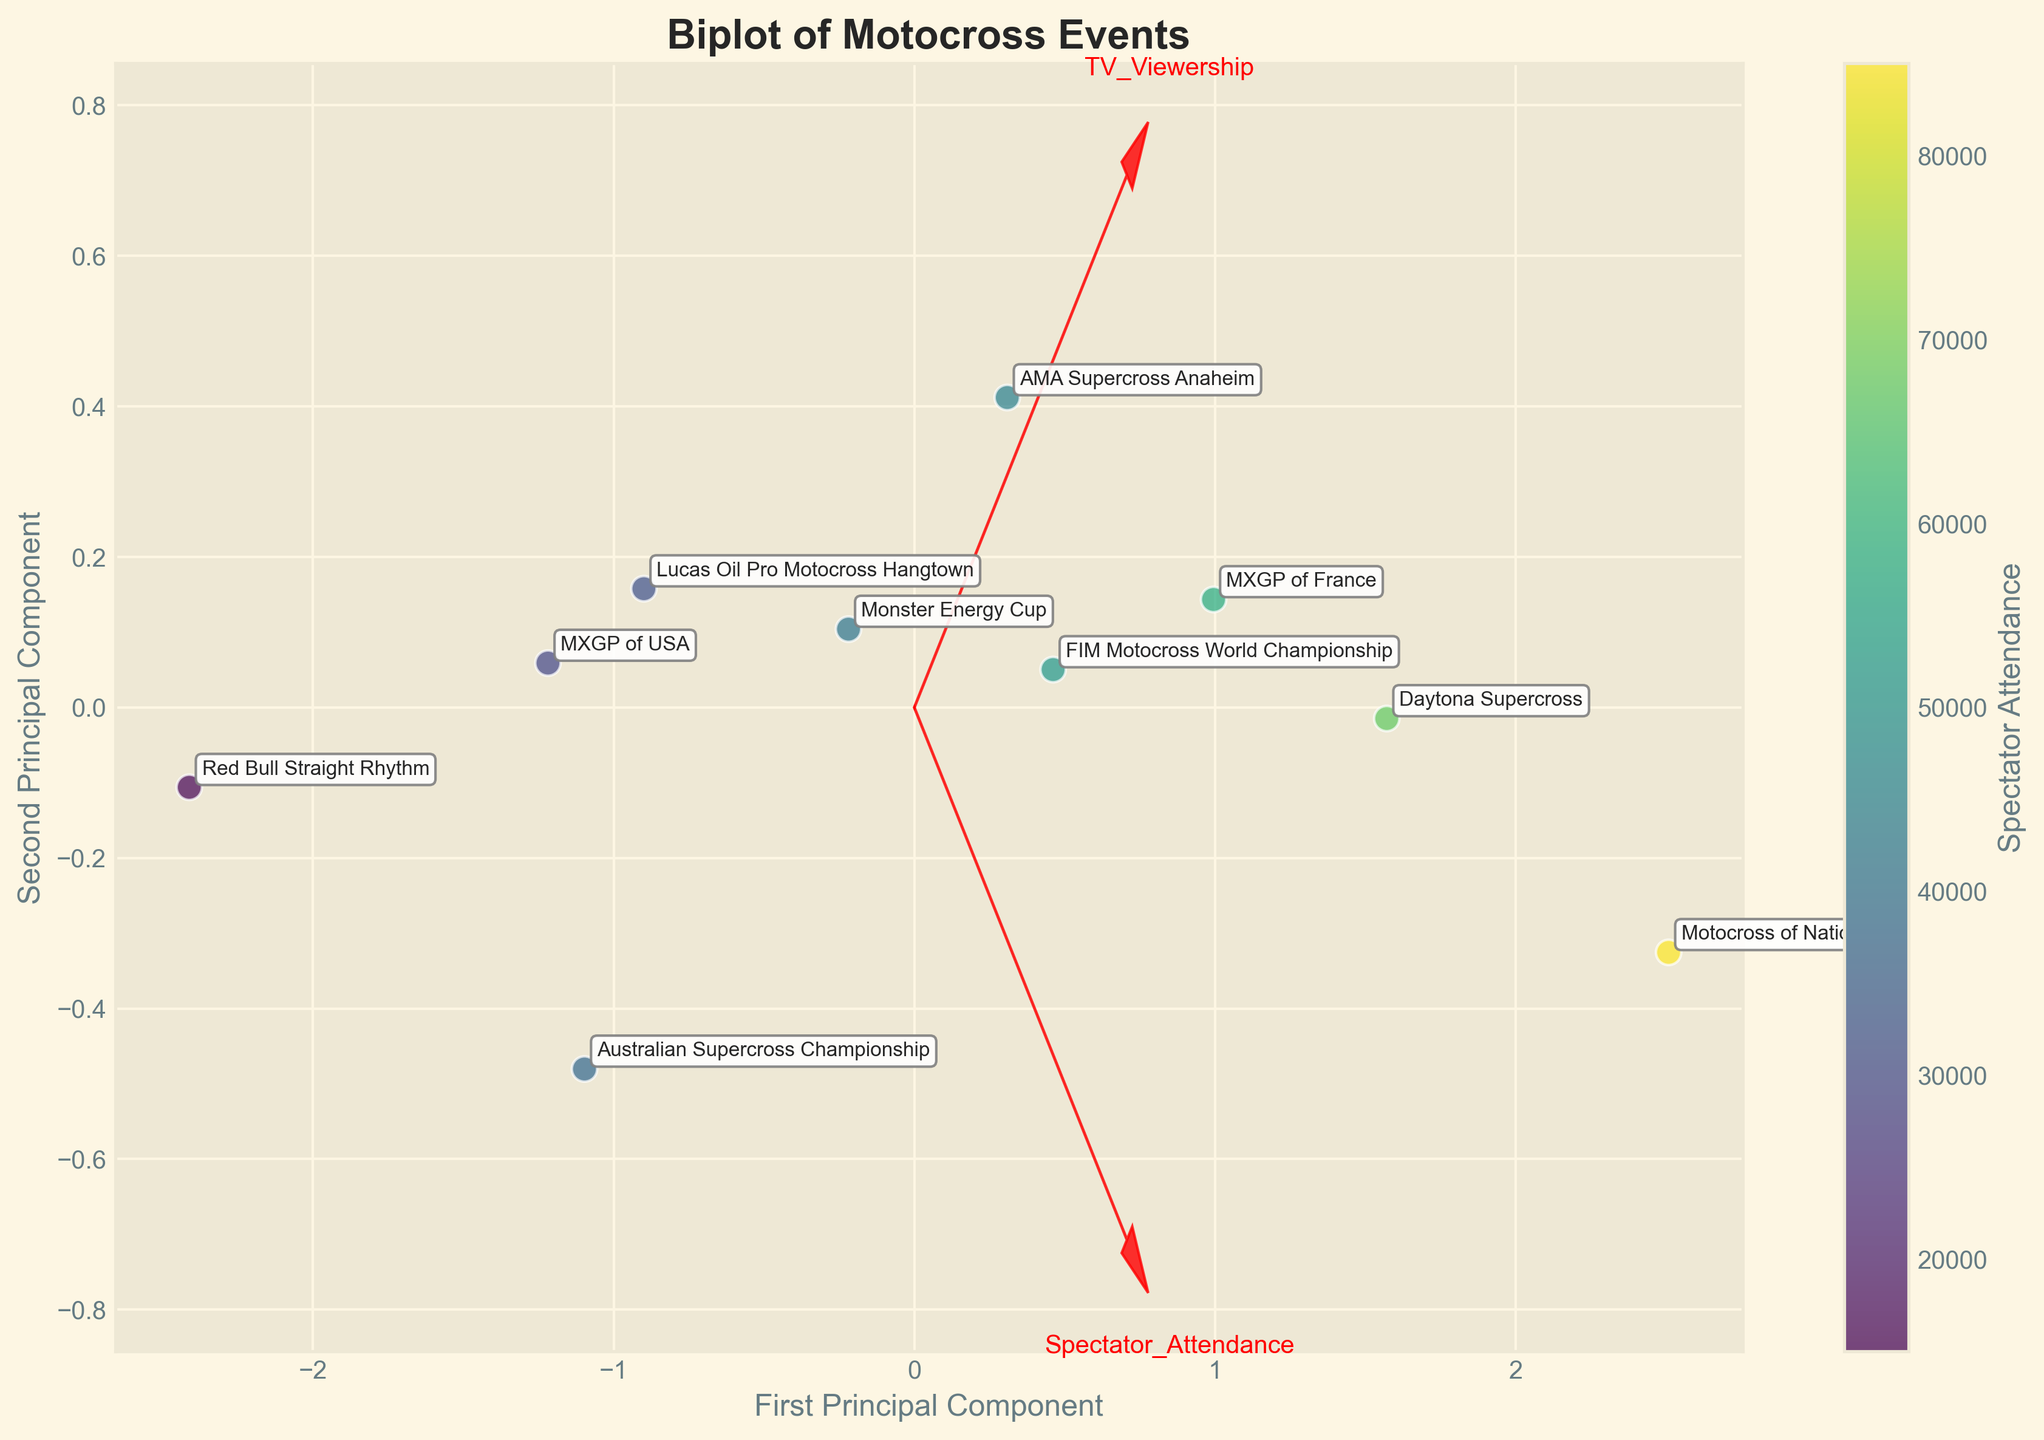What title is given to the figure? The title is usually placed at the top of the plot and it gives an overview of the content of the graph. The title says "Biplot of Motocross Events".
Answer: Biplot of Motocross Events What does the color represent in this plot? Color in the plot signifies the Spectator Attendance. This can be confirmed by the colorbar labeled "Spectator Attendance".
Answer: Spectator Attendance How many principal components are shown in this biplot? The two principal components are labeled as "First Principal Component" and "Second Principal Component" on the respective axes.
Answer: Two Which event has the highest Spectator Attendance? The event with the highest Spectator Attendance will be placed at the point on the plot that corresponds to the highest color intensity according to the colorbar. The "Motocross of Nations" event has the most intense color.
Answer: Motocross of Nations How are the PCA feature vectors indicated in the biplot? PCA feature vectors are typically indicated by arrows, and in this plot, they are red arrows originating from the center (0,0).
Answer: Red arrows Which principal component has a greater contribution from TV Viewership? By looking at the direction of the feature vector for TV Viewership, we see that it lays heavily on the first principal component axis compared to the second.
Answer: First Principal Component Which event type is associated with the lowest spectator attendance? By finding the lowest value on the color scale (lightest color) and mapping it to the event label, "Red Bull Straight Rhythm" has the lightest marking indicating the lowest spectator attendance.
Answer: Special, Red Bull Straight Rhythm Are there more stadium events or international events closer to each other in PCA space? By observing the plot, we count the clustered points by event type. There appear to be more International events (e.g., MXGP of France, FIM Motocross World Championship) closer together compared to Stadium events.
Answer: International events What is the approximate number of data points plotted? By counting the annotated event labels, slightly altered for visible rendering, there are 10 data points on the biplot.
Answer: 10 